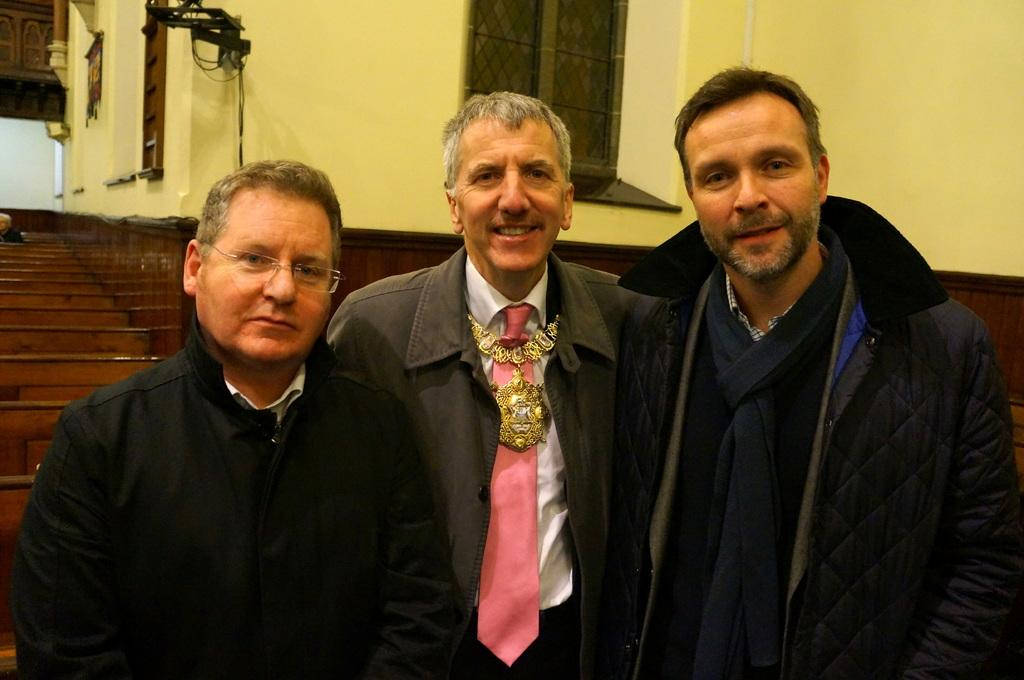What are the people in the image doing? The people in the image are standing. What color clothes are the men wearing? The men are wearing black clothes. Can you describe any architectural features in the image? Yes, there is a window in the image. How many brothers can be seen in the image? There is no mention of brothers in the image, so it cannot be determined from the image. 